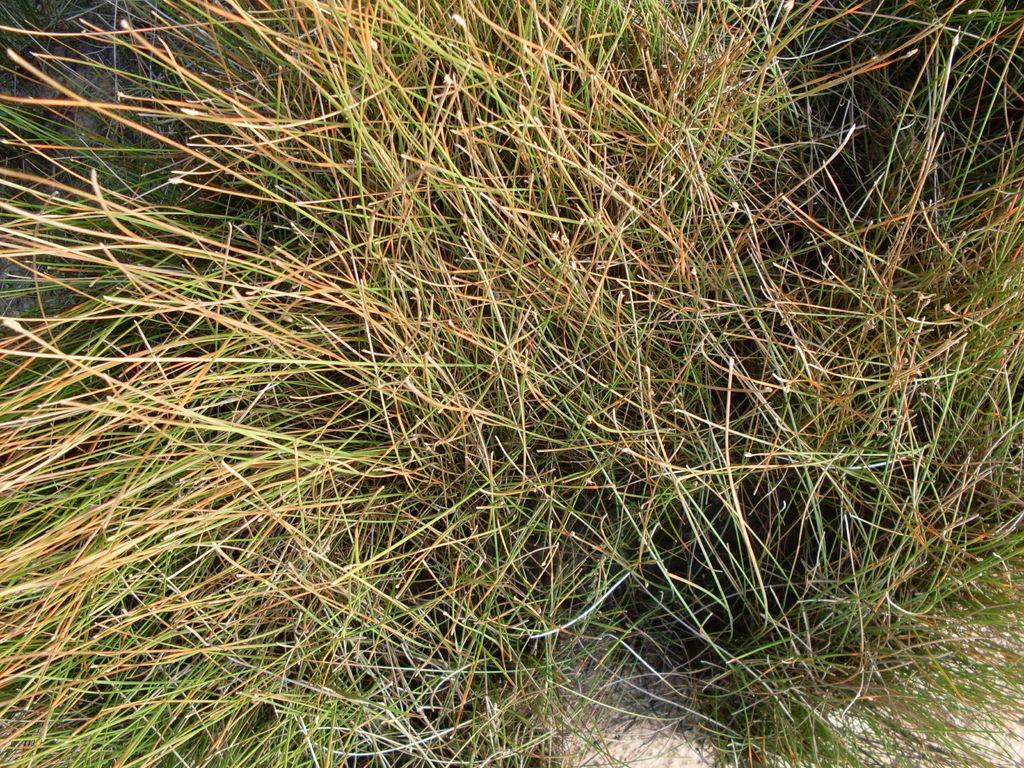Can you describe this image briefly? The picture consists of grass. 